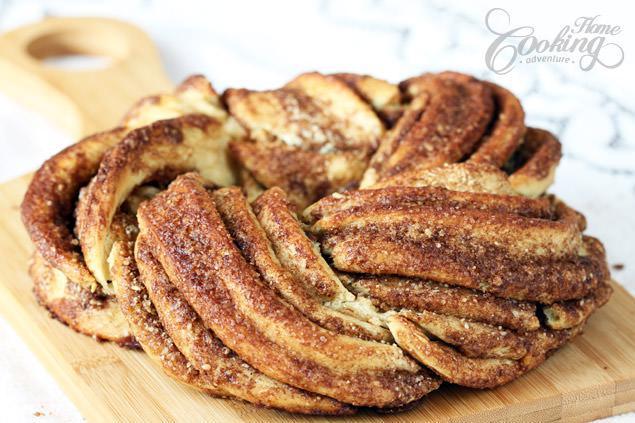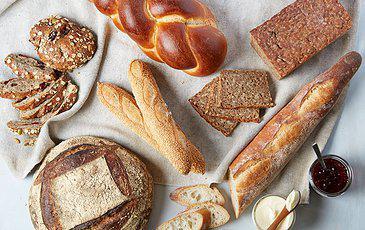The first image is the image on the left, the second image is the image on the right. Assess this claim about the two images: "Each image contains at least four different bread items, one image shows breads on unpainted wood, and no image includes unbaked dough.". Correct or not? Answer yes or no. No. The first image is the image on the left, the second image is the image on the right. For the images shown, is this caption "There are kitchen utensils visible in the right image." true? Answer yes or no. Yes. 